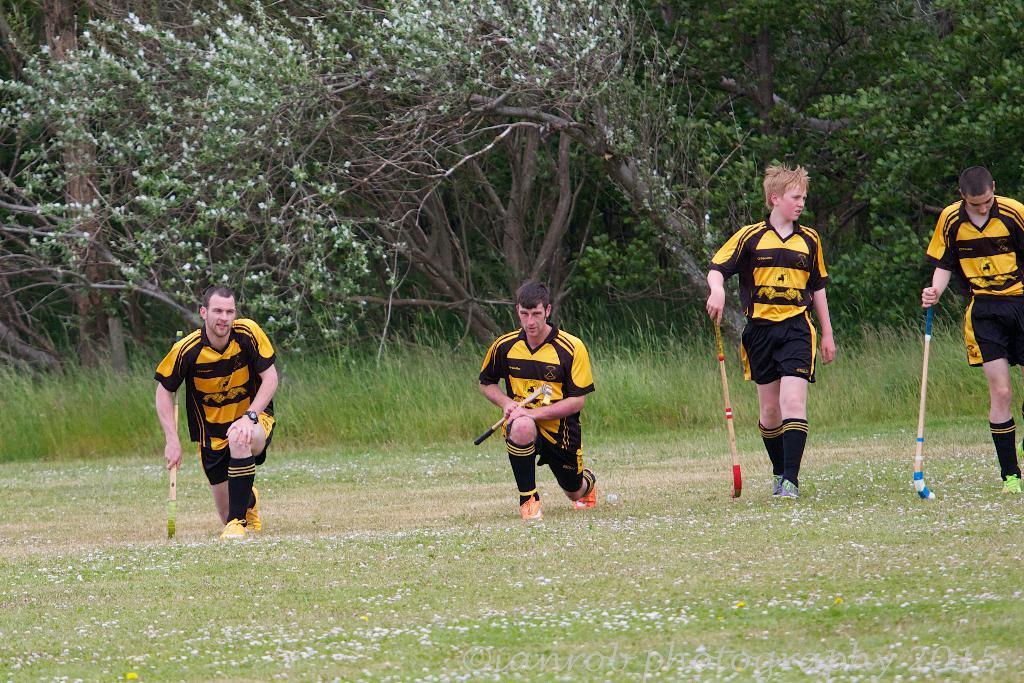In one or two sentences, can you explain what this image depicts? There are four people. They are holding hockey sticks. On the ground there is grass. In the back there are plants and trees. 